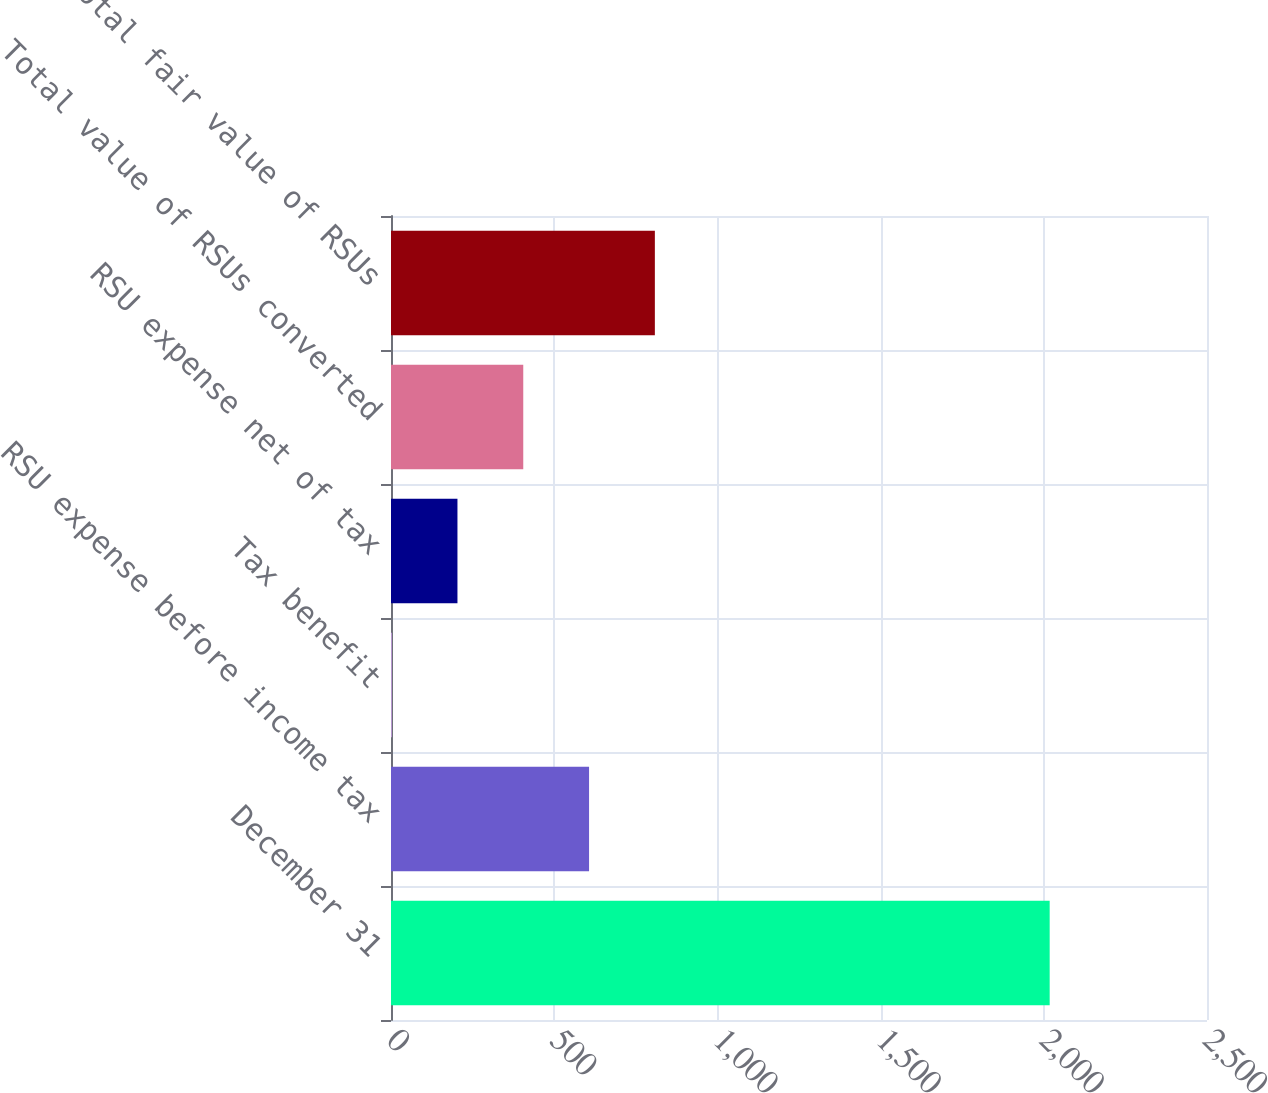<chart> <loc_0><loc_0><loc_500><loc_500><bar_chart><fcel>December 31<fcel>RSU expense before income tax<fcel>Tax benefit<fcel>RSU expense net of tax<fcel>Total value of RSUs converted<fcel>Total fair value of RSUs<nl><fcel>2018<fcel>606.8<fcel>2<fcel>203.6<fcel>405.2<fcel>808.4<nl></chart> 